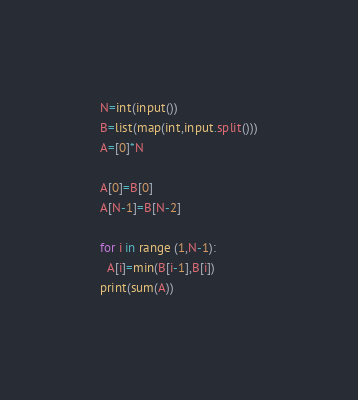Convert code to text. <code><loc_0><loc_0><loc_500><loc_500><_Python_>N=int(input())
B=list(map(int,input.split()))
A=[0]*N

A[0]=B[0]
A[N-1]=B[N-2]

for i in range (1,N-1):
  A[i]=min(B[i-1],B[i])
print(sum(A))</code> 